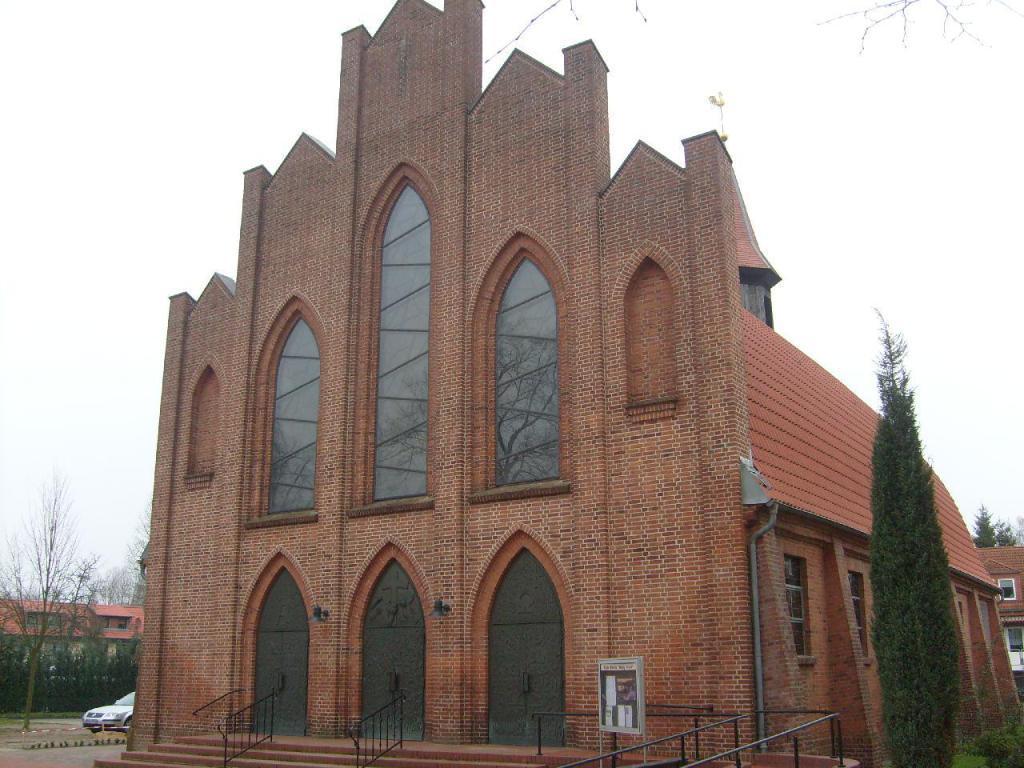Could you give a brief overview of what you see in this image? This is a picture of a cathedral. to the right there is a tree. In the top right there is a building and tree. On the left there is a car parked. there are trees and a building. Sky is cloudy. In the foreground there is staircase, door and railing. 